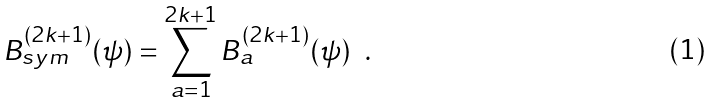<formula> <loc_0><loc_0><loc_500><loc_500>B ^ { ( 2 k + 1 ) } _ { s y m } ( \psi ) = \sum _ { a = 1 } ^ { 2 k + 1 } B ^ { ( 2 k + 1 ) } _ { a } ( \psi ) \ \ .</formula> 